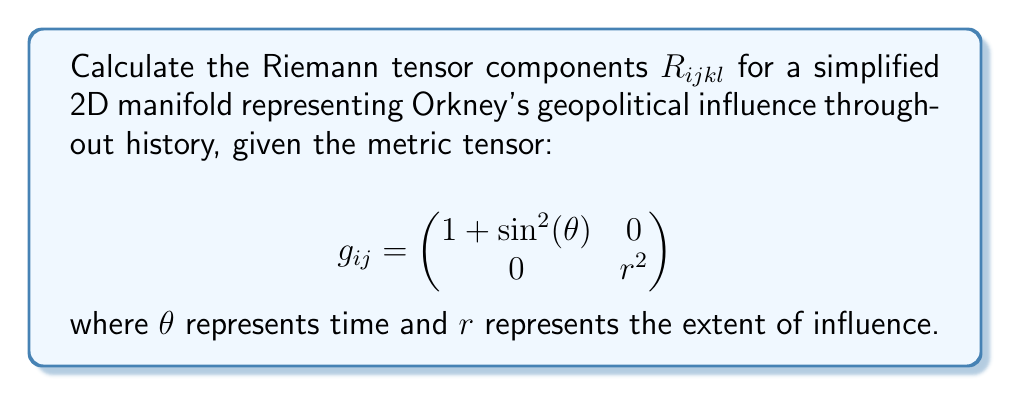Could you help me with this problem? To evaluate the Riemann tensor, we'll follow these steps:

1) First, calculate the Christoffel symbols $\Gamma^i_{jk}$ using the formula:
   $$\Gamma^i_{jk} = \frac{1}{2}g^{im}(\partial_j g_{km} + \partial_k g_{jm} - \partial_m g_{jk})$$

2) The non-zero Christoffel symbols are:
   $$\Gamma^1_{11} = \frac{\sin\theta\cos\theta}{1+\sin^2\theta}$$
   $$\Gamma^2_{12} = \Gamma^2_{21} = \frac{1}{r}$$

3) Now, use the Riemann tensor formula:
   $$R_{ijkl} = \partial_k \Gamma^m_{il} - \partial_l \Gamma^m_{ik} + \Gamma^m_{kn}\Gamma^n_{il} - \Gamma^m_{ln}\Gamma^n_{ik}$$

4) Calculate the non-zero components:
   $$R_{1212} = \partial_1 \Gamma^2_{22} - \partial_2 \Gamma^2_{12} + \Gamma^2_{1n}\Gamma^n_{22} - \Gamma^2_{2n}\Gamma^n_{12}$$
   $$= 0 - \partial_2 (\frac{1}{r}) + 0 - 0 = \frac{1}{r^2}$$

5) The other non-zero component is $R_{2121} = -R_{1212}$

6) All other components are zero due to symmetry or antisymmetry properties of the Riemann tensor.

This simplified model represents Orkney's geopolitical influence as a curved space-time, where the curvature (represented by the Riemann tensor) indicates the strength and variation of influence over time and space.
Answer: $R_{1212} = \frac{1}{r^2}$, $R_{2121} = -\frac{1}{r^2}$, all other components = 0 